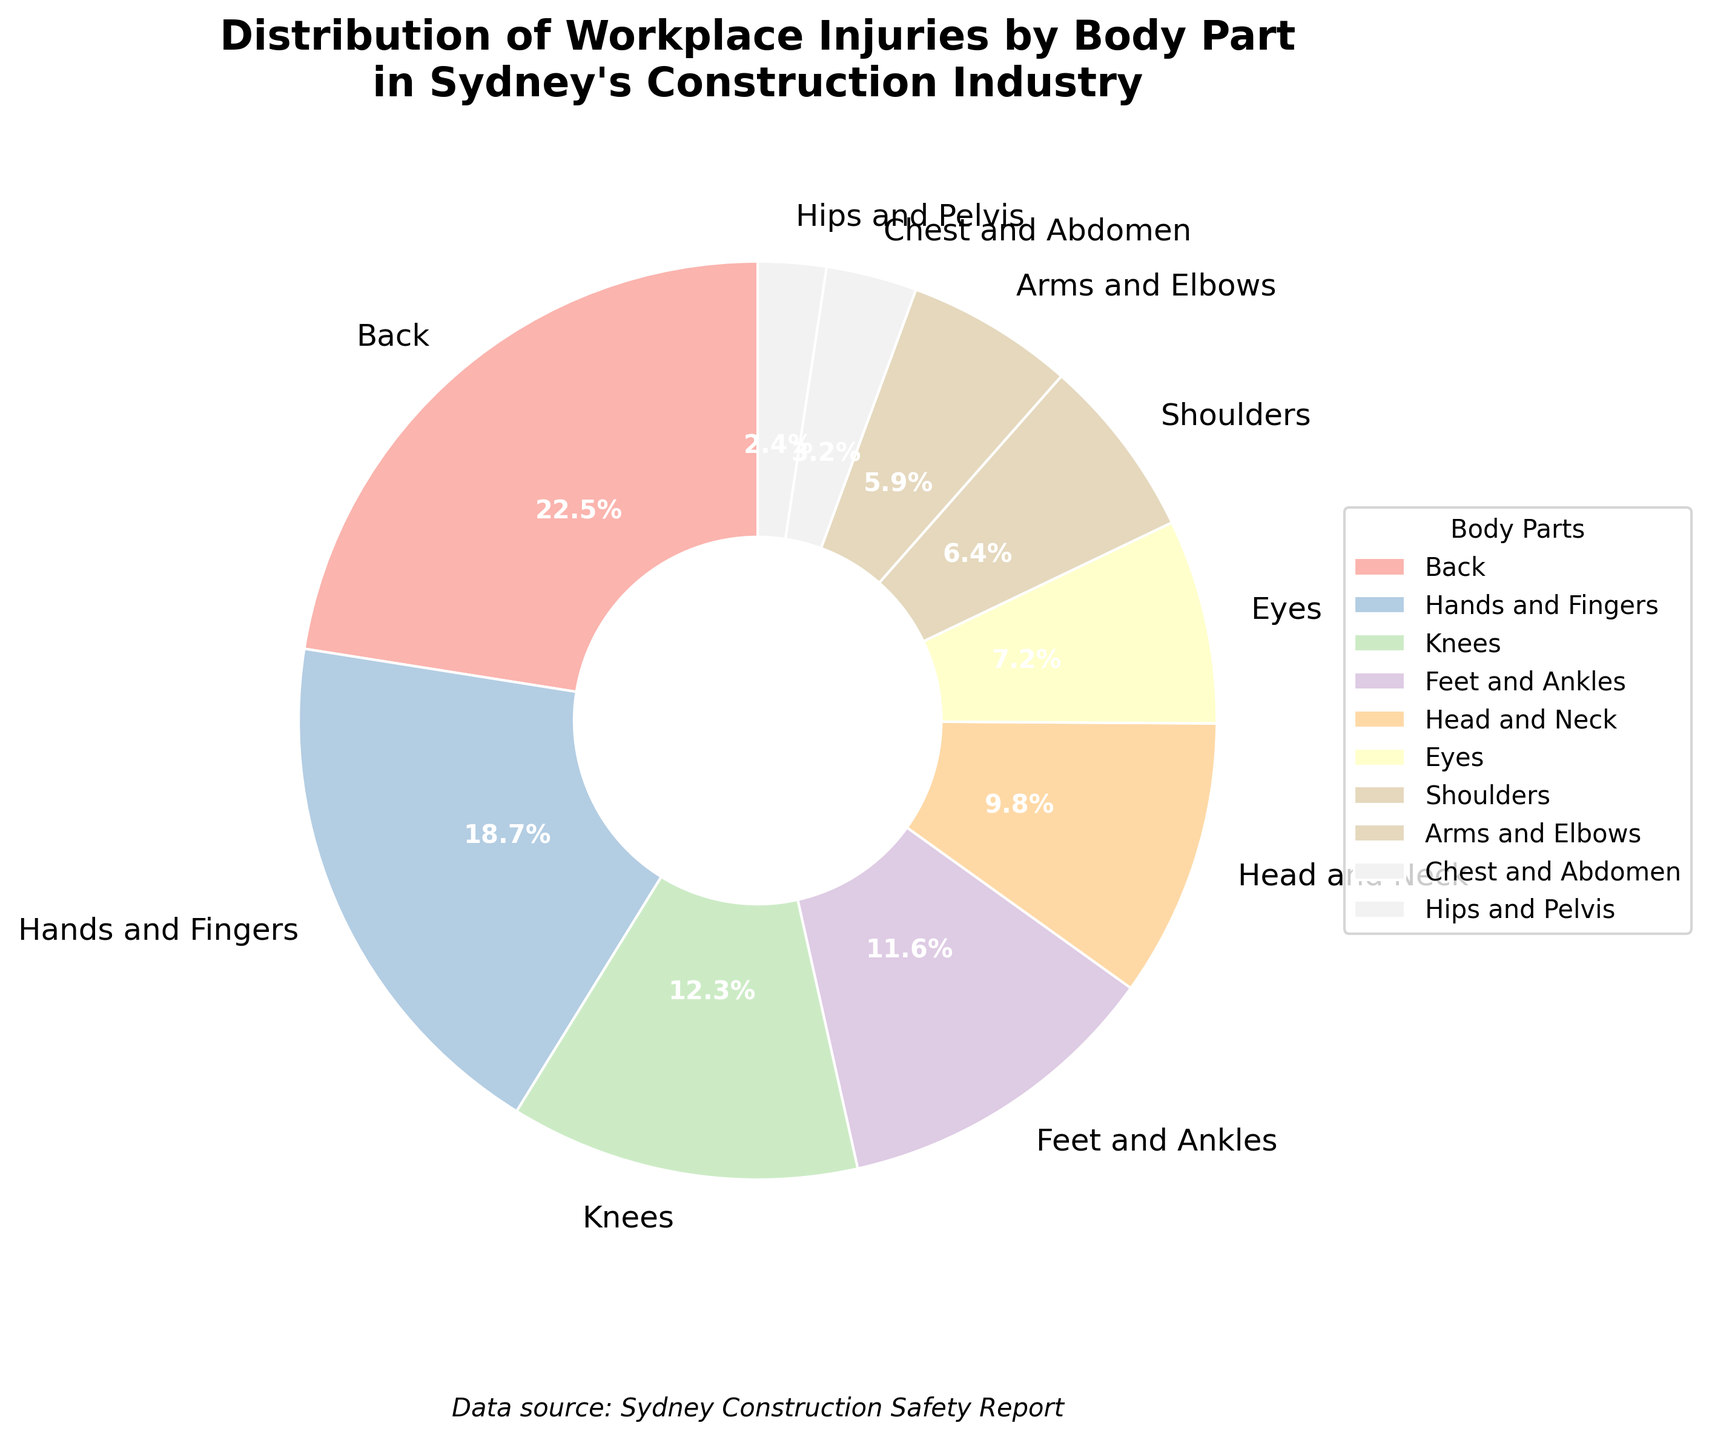What body part has the highest percentage of workplace injuries in Sydney's construction industry? The figure shows that the section with "Back" has the largest fraction of the pie chart.
Answer: Back What is the combined percentage of injuries for knees, feet and ankles? Add the percentages for "Knees" and "Feet and Ankles". 12.3% + 11.6% = 23.9%
Answer: 23.9% How does the percentage of injuries to the eyes compare to the shoulders? Look at the pie chart segments labeled "Eyes" and "Shoulders", and compare their percentages: 7.2% and 6.4%. 7.2% is greater than 6.4%.
Answer: Eyes have a higher percentage What percentage of injuries occurred to the lower body parts (hips and pelvis, knees, feet and ankles)? Sum the percentages for "Hips and Pelvis", "Knees", and "Feet and Ankles". 2.4% + 12.3% + 11.6% = 26.3%
Answer: 26.3% Which injury is less common: chest and abdomen or arms and elbows? Compare the percentages for "Chest and Abdomen" (3.2%) and "Arms and Elbows" (5.9%). 3.2% is less than 5.9%.
Answer: Chest and Abdomen What is the percentage of injuries to head and neck compared to knees? Find the percentage of "Head and Neck" (9.8%) and "Knees" (12.3%), 9.8% is less than 12.3%.
Answer: Head and Neck have fewer injuries What portion of the injuries are to the upper body parts (shoulders, arms and elbows, chest and abdomen)? Sum the provided percentages: 6.4% (Shoulders) + 5.9% (Arms and Elbows) + 3.2% (Chest and Abdomen) = 15.5%
Answer: 15.5% If you combined the injuries of hands and fingers with shoulders, would they surpass the injuries for back? Add the percentages of "Hands and Fingers" (18.7%) and "Shoulders" (6.4%), then compare to "Back" (22.5%). 18.7% + 6.4% = 25.1%, which is greater than 22.5%.
Answer: Yes By how much do injuries to the back exceed injuries to the hips and pelvis? Subtract the percentage of "Hips and Pelvis" (2.4%) from "Back" (22.5%). 22.5% - 2.4% = 20.1%
Answer: 20.1% What part of the body has the third highest percentage of workplace injuries? Identify and sort the percentages, the top three are "Back" (22.5%), "Hands and Fingers" (18.7%), and "Knees" (12.3%)
Answer: Knees 